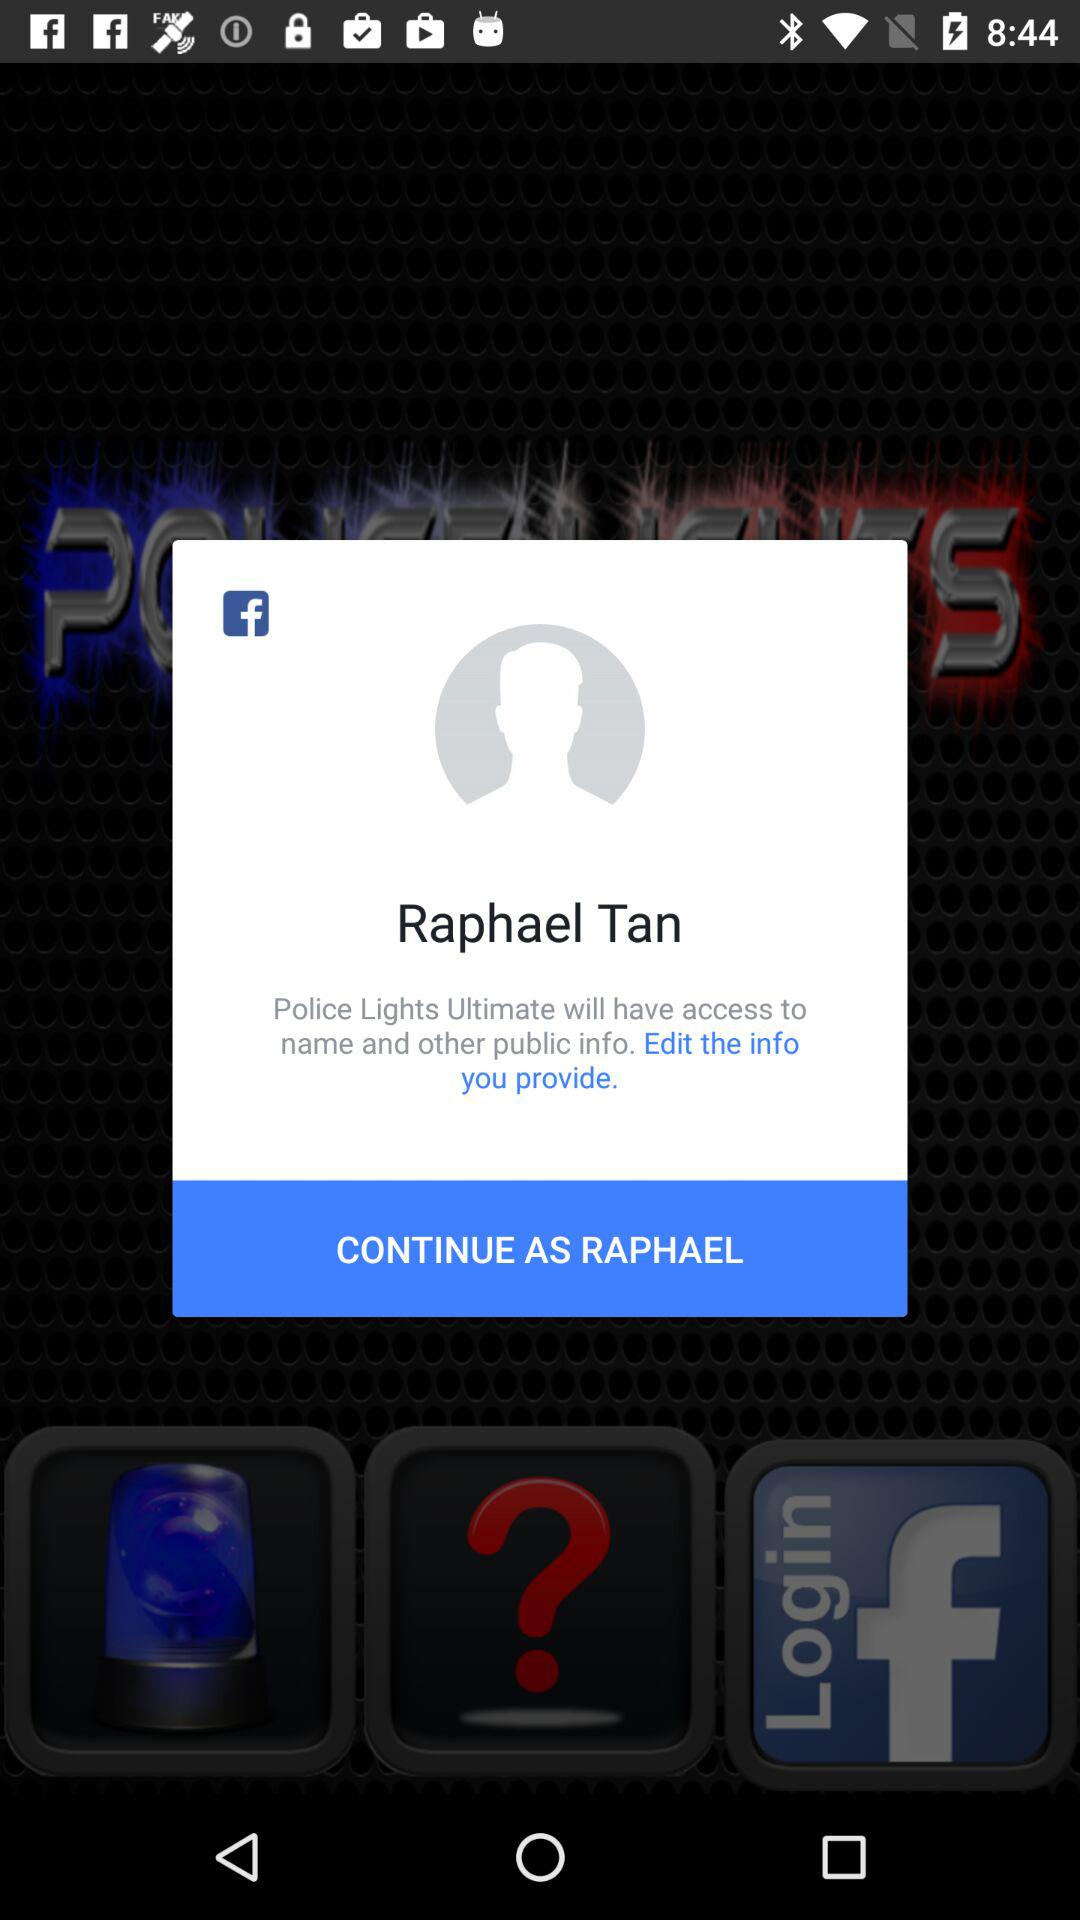What application has asked for permission? The application that has asked for permission is "Police Lights Ultimate". 